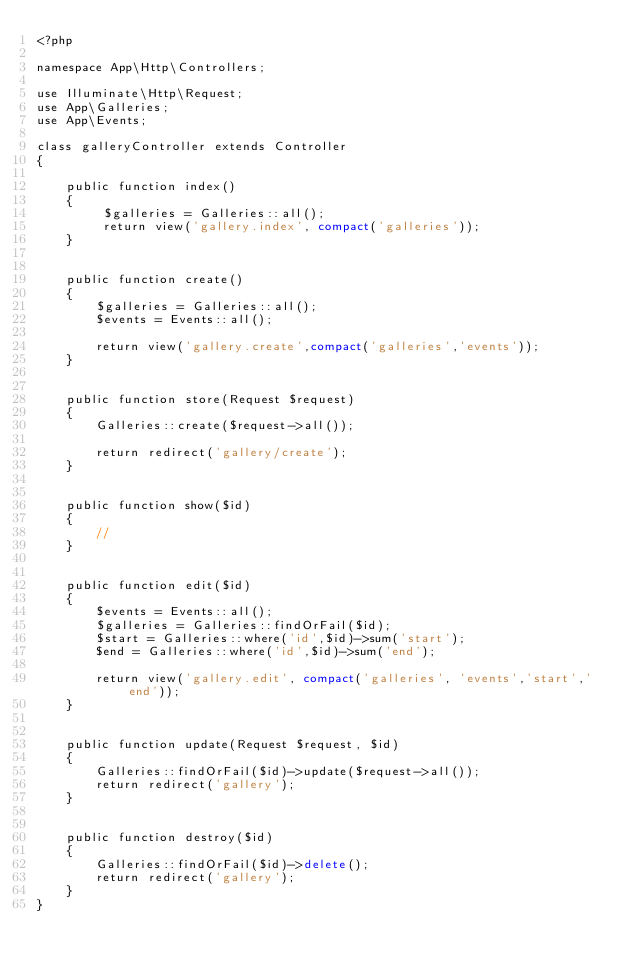<code> <loc_0><loc_0><loc_500><loc_500><_PHP_><?php

namespace App\Http\Controllers;

use Illuminate\Http\Request;  
use App\Galleries;
use App\Events;

class galleryController extends Controller
{
     
    public function index()
    { 
         $galleries = Galleries::all(); 
         return view('gallery.index', compact('galleries'));
    }

     
    public function create()
    {
        $galleries = Galleries::all();
        $events = Events::all();

        return view('gallery.create',compact('galleries','events'));    
    }

     
    public function store(Request $request)
    {
        Galleries::create($request->all());

        return redirect('gallery/create');
    }

     
    public function show($id)
    {
        //
    }

     
    public function edit($id)
    {
        $events = Events::all();
        $galleries = Galleries::findOrFail($id);
        $start = Galleries::where('id',$id)->sum('start');
        $end = Galleries::where('id',$id)->sum('end');
 
        return view('gallery.edit', compact('galleries', 'events','start','end'));
    }

     
    public function update(Request $request, $id)
    {
        Galleries::findOrFail($id)->update($request->all());
        return redirect('gallery');
    }

     
    public function destroy($id)
    {
        Galleries::findOrFail($id)->delete();
        return redirect('gallery');
    }
}
</code> 